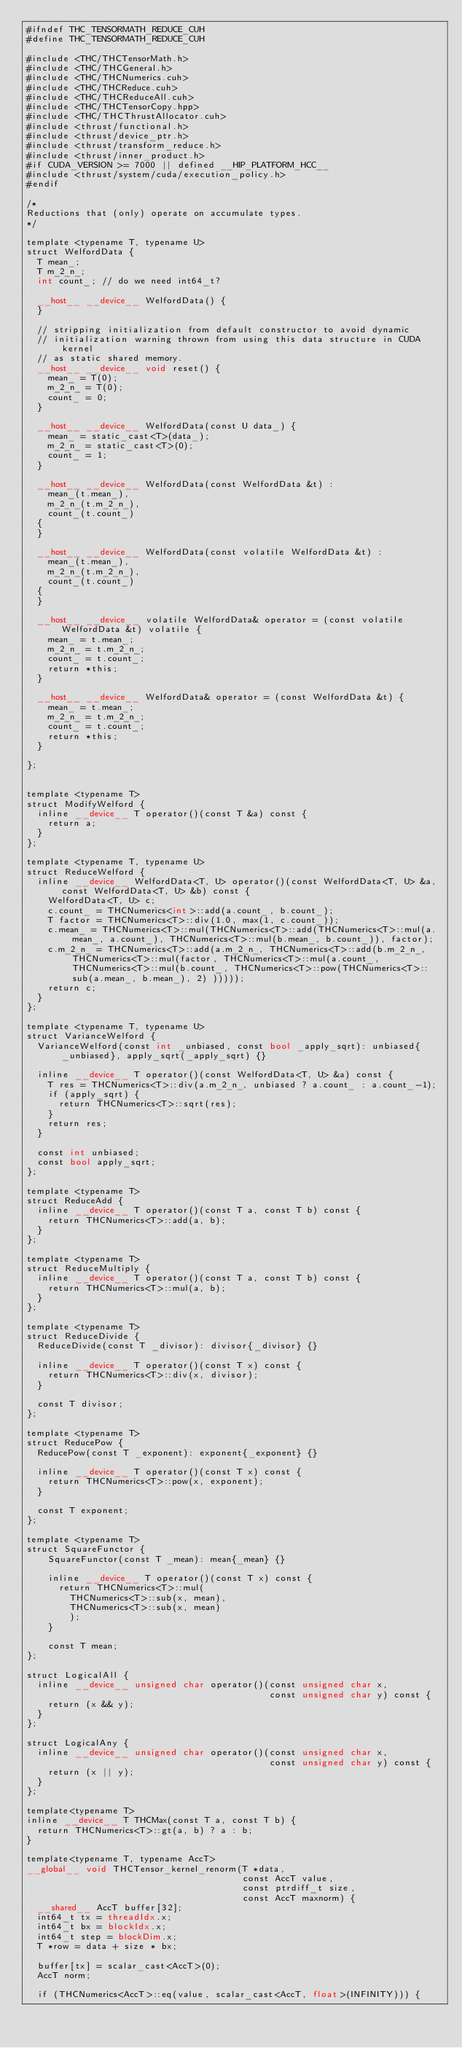Convert code to text. <code><loc_0><loc_0><loc_500><loc_500><_Cuda_>#ifndef THC_TENSORMATH_REDUCE_CUH
#define THC_TENSORMATH_REDUCE_CUH

#include <THC/THCTensorMath.h>
#include <THC/THCGeneral.h>
#include <THC/THCNumerics.cuh>
#include <THC/THCReduce.cuh>
#include <THC/THCReduceAll.cuh>
#include <THC/THCTensorCopy.hpp>
#include <THC/THCThrustAllocator.cuh>
#include <thrust/functional.h>
#include <thrust/device_ptr.h>
#include <thrust/transform_reduce.h>
#include <thrust/inner_product.h>
#if CUDA_VERSION >= 7000 || defined __HIP_PLATFORM_HCC__
#include <thrust/system/cuda/execution_policy.h>
#endif

/*
Reductions that (only) operate on accumulate types.
*/

template <typename T, typename U>
struct WelfordData {
  T mean_;
  T m_2_n_;
  int count_; // do we need int64_t?

  __host__ __device__ WelfordData() {
  }

  // stripping initialization from default constructor to avoid dynamic
  // initialization warning thrown from using this data structure in CUDA kernel
  // as static shared memory.
  __host__ __device__ void reset() {
    mean_ = T(0);
    m_2_n_ = T(0);
    count_ = 0;
  }

  __host__ __device__ WelfordData(const U data_) {
    mean_ = static_cast<T>(data_);
    m_2_n_ = static_cast<T>(0);
    count_ = 1;
  }

  __host__ __device__ WelfordData(const WelfordData &t) :
    mean_(t.mean_),
    m_2_n_(t.m_2_n_),
    count_(t.count_)
  {
  }

  __host__ __device__ WelfordData(const volatile WelfordData &t) :
    mean_(t.mean_),
    m_2_n_(t.m_2_n_),
    count_(t.count_)
  {
  }

  __host__ __device__ volatile WelfordData& operator = (const volatile WelfordData &t) volatile {
    mean_ = t.mean_;
    m_2_n_ = t.m_2_n_;
    count_ = t.count_;
    return *this;
  }

  __host__ __device__ WelfordData& operator = (const WelfordData &t) {
    mean_ = t.mean_;
    m_2_n_ = t.m_2_n_;
    count_ = t.count_;
    return *this;
  }

};


template <typename T>
struct ModifyWelford {
  inline __device__ T operator()(const T &a) const {
    return a;
  }
};

template <typename T, typename U>
struct ReduceWelford {
  inline __device__ WelfordData<T, U> operator()(const WelfordData<T, U> &a, const WelfordData<T, U> &b) const {
    WelfordData<T, U> c;
    c.count_ = THCNumerics<int>::add(a.count_, b.count_);
    T factor = THCNumerics<T>::div(1.0, max(1, c.count_));
    c.mean_ = THCNumerics<T>::mul(THCNumerics<T>::add(THCNumerics<T>::mul(a.mean_, a.count_), THCNumerics<T>::mul(b.mean_, b.count_)), factor);
    c.m_2_n_ = THCNumerics<T>::add(a.m_2_n_, THCNumerics<T>::add(b.m_2_n_, THCNumerics<T>::mul(factor, THCNumerics<T>::mul(a.count_, THCNumerics<T>::mul(b.count_, THCNumerics<T>::pow(THCNumerics<T>::sub(a.mean_, b.mean_), 2) )))));
    return c;
  }
};

template <typename T, typename U>
struct VarianceWelford {
  VarianceWelford(const int _unbiased, const bool _apply_sqrt): unbiased{_unbiased}, apply_sqrt(_apply_sqrt) {}

  inline __device__ T operator()(const WelfordData<T, U> &a) const {
    T res = THCNumerics<T>::div(a.m_2_n_, unbiased ? a.count_ : a.count_-1);
    if (apply_sqrt) {
      return THCNumerics<T>::sqrt(res);
    }
    return res;
  }

  const int unbiased;
  const bool apply_sqrt;
};

template <typename T>
struct ReduceAdd {
  inline __device__ T operator()(const T a, const T b) const {
    return THCNumerics<T>::add(a, b);
  }
};

template <typename T>
struct ReduceMultiply {
  inline __device__ T operator()(const T a, const T b) const {
    return THCNumerics<T>::mul(a, b);
  }
};

template <typename T>
struct ReduceDivide {
  ReduceDivide(const T _divisor): divisor{_divisor} {}

  inline __device__ T operator()(const T x) const {
    return THCNumerics<T>::div(x, divisor);
  }

  const T divisor;
};

template <typename T>
struct ReducePow {
  ReducePow(const T _exponent): exponent{_exponent} {}

  inline __device__ T operator()(const T x) const {
    return THCNumerics<T>::pow(x, exponent);
  }

  const T exponent;
};

template <typename T>
struct SquareFunctor {
    SquareFunctor(const T _mean): mean{_mean} {}

    inline __device__ T operator()(const T x) const {
      return THCNumerics<T>::mul(
        THCNumerics<T>::sub(x, mean),
        THCNumerics<T>::sub(x, mean)
        );
    }

    const T mean;
};

struct LogicalAll {
  inline __device__ unsigned char operator()(const unsigned char x,
                                             const unsigned char y) const {
    return (x && y);
  }
};

struct LogicalAny {
  inline __device__ unsigned char operator()(const unsigned char x,
                                             const unsigned char y) const {
    return (x || y);
  }
};

template<typename T>
inline __device__ T THCMax(const T a, const T b) {
  return THCNumerics<T>::gt(a, b) ? a : b;
}

template<typename T, typename AccT>
__global__ void THCTensor_kernel_renorm(T *data,
                                        const AccT value,
                                        const ptrdiff_t size,
                                        const AccT maxnorm) {
  __shared__ AccT buffer[32];
  int64_t tx = threadIdx.x;
  int64_t bx = blockIdx.x;
  int64_t step = blockDim.x;
  T *row = data + size * bx;

  buffer[tx] = scalar_cast<AccT>(0);
  AccT norm;

  if (THCNumerics<AccT>::eq(value, scalar_cast<AccT, float>(INFINITY))) {</code> 